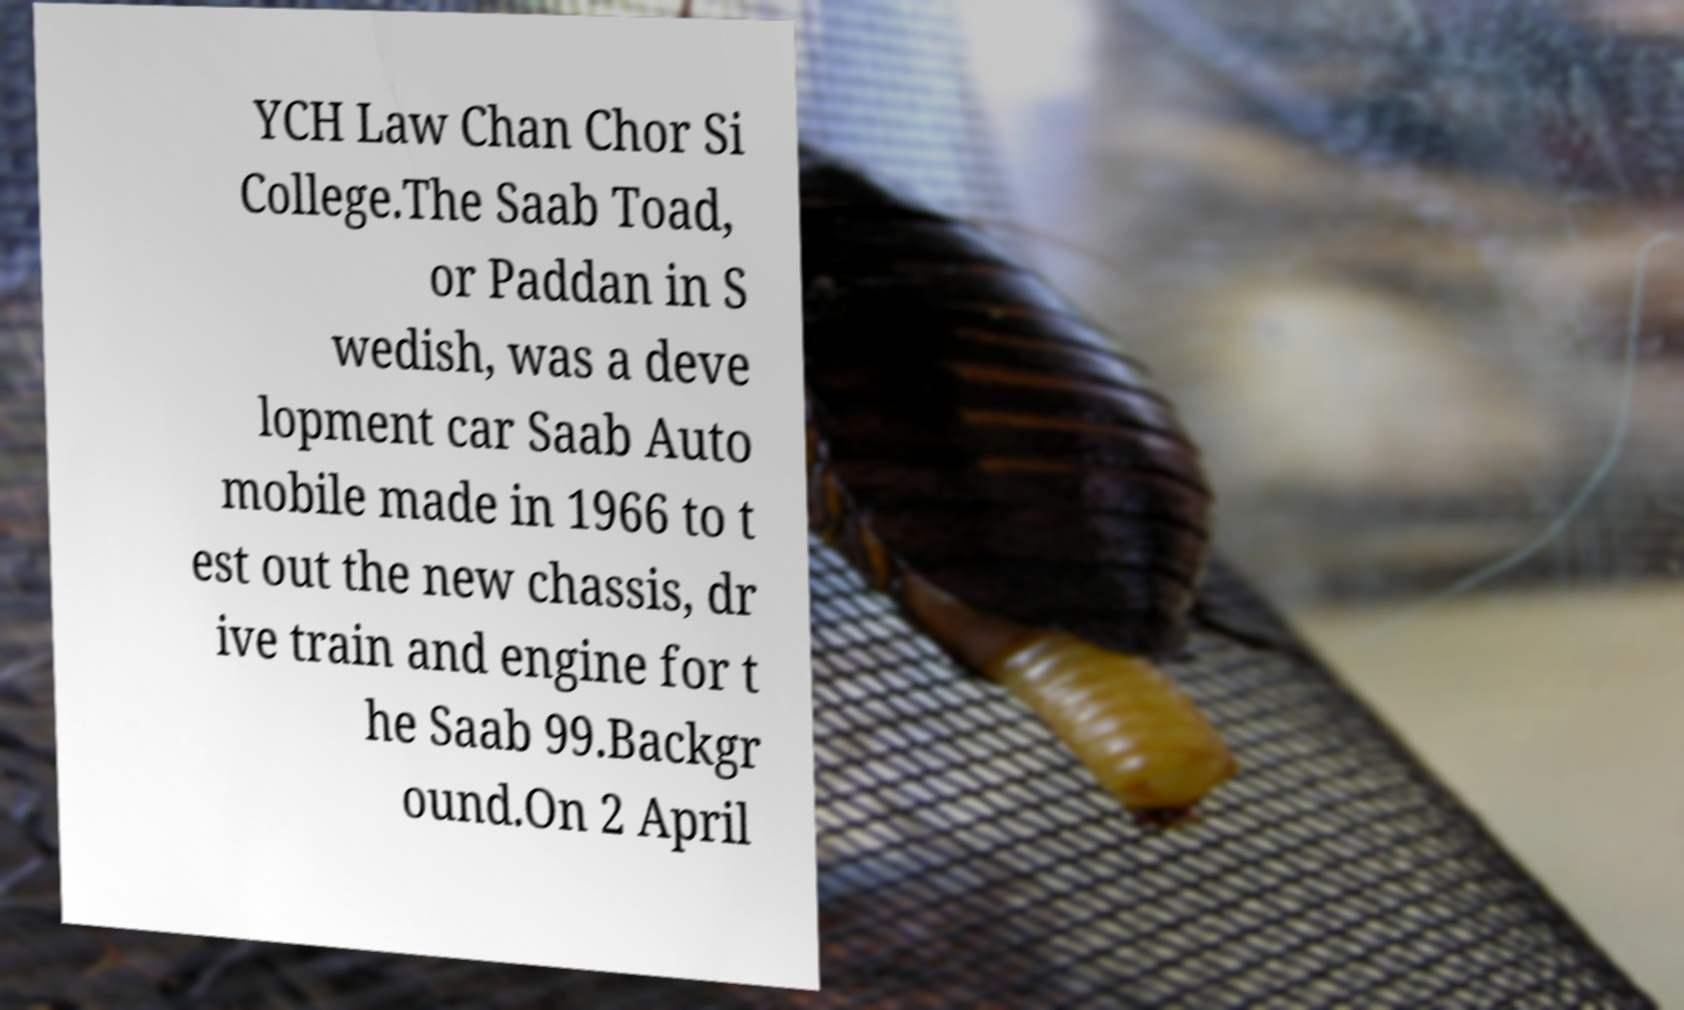Can you read and provide the text displayed in the image?This photo seems to have some interesting text. Can you extract and type it out for me? YCH Law Chan Chor Si College.The Saab Toad, or Paddan in S wedish, was a deve lopment car Saab Auto mobile made in 1966 to t est out the new chassis, dr ive train and engine for t he Saab 99.Backgr ound.On 2 April 